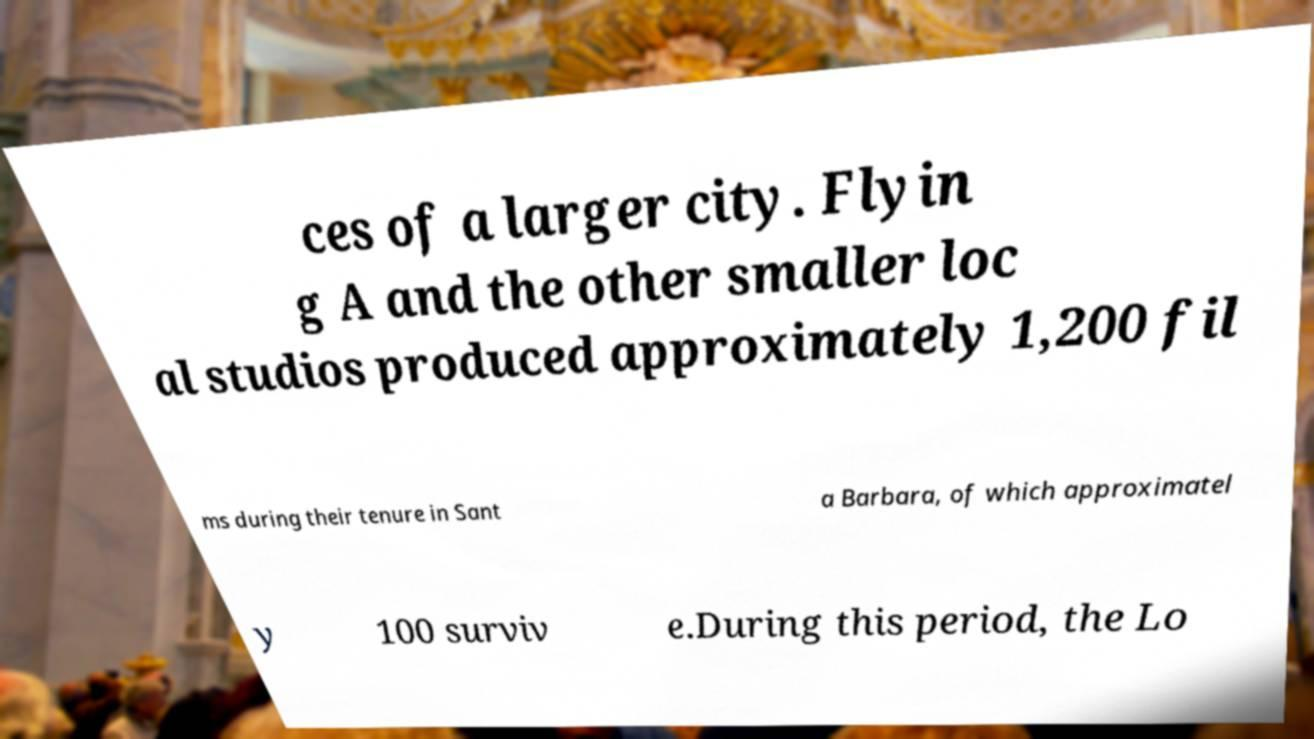There's text embedded in this image that I need extracted. Can you transcribe it verbatim? ces of a larger city. Flyin g A and the other smaller loc al studios produced approximately 1,200 fil ms during their tenure in Sant a Barbara, of which approximatel y 100 surviv e.During this period, the Lo 